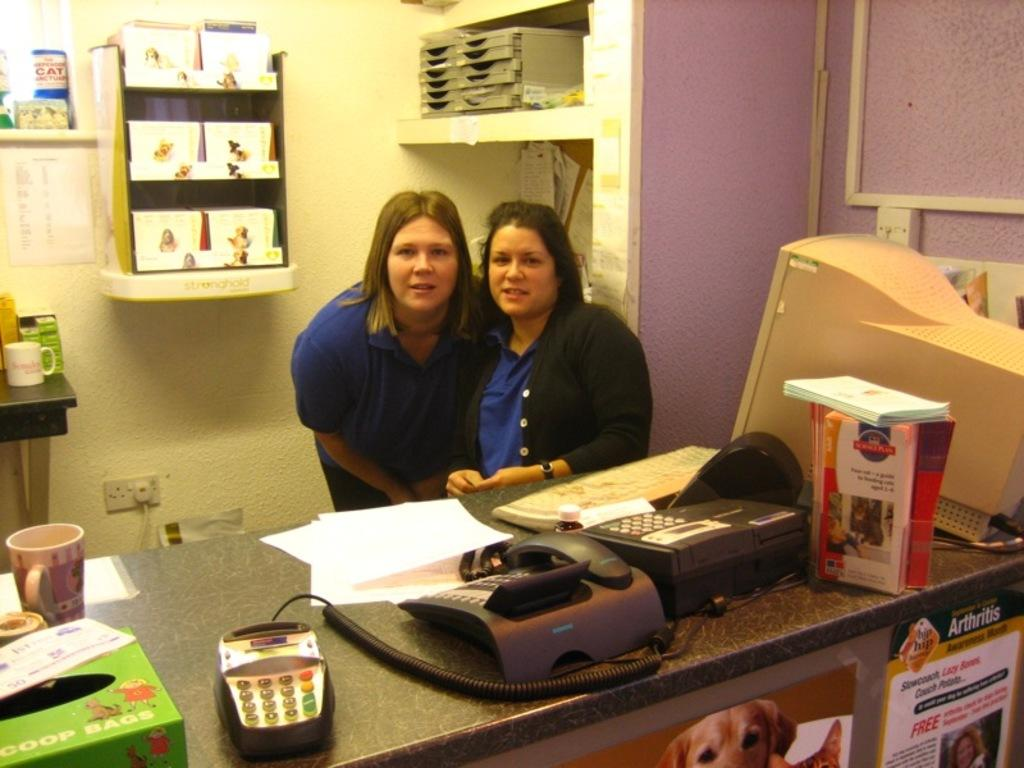How many women are in the image? There are two women in the image. What are the positions of the women in the image? One woman is standing, and the other is seated. What type of electronic device is present in the image? There is a desktop computer on a table in the image. What communication device is visible in the image? There is a telephone in the image. What type of furniture is visible in the image? There is a shelf visible in the image. What type of brain surgery is being performed on the woman in the image? There is no brain surgery or any medical procedure being performed in the image. 